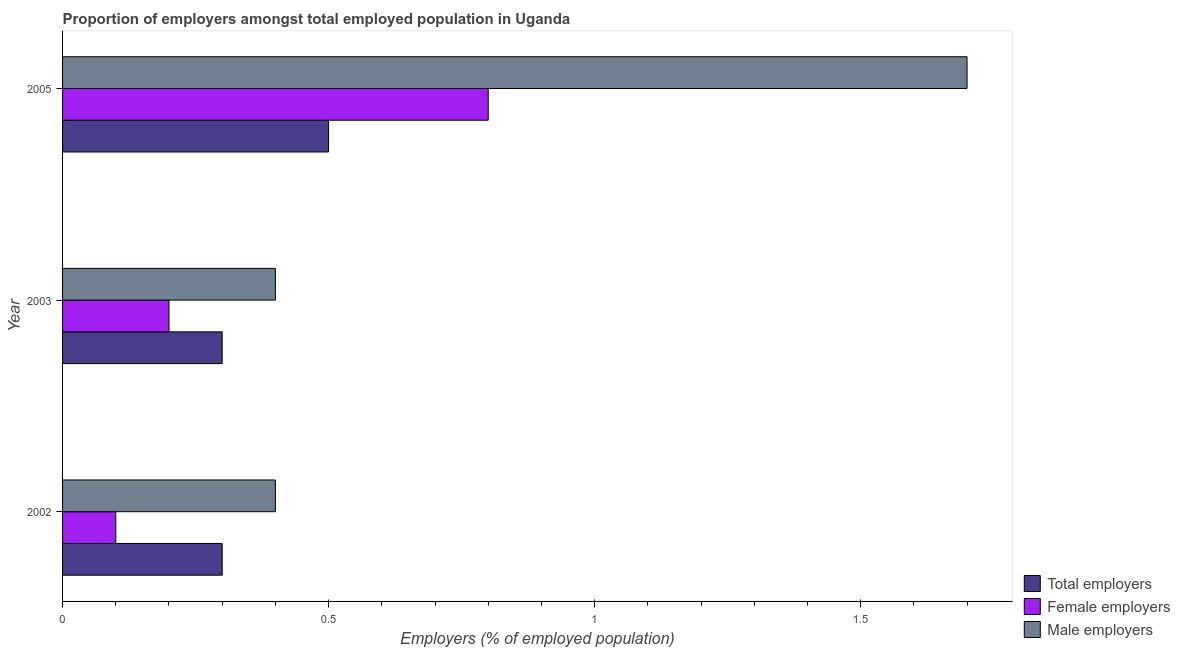How many different coloured bars are there?
Your answer should be compact. 3. How many groups of bars are there?
Your answer should be compact. 3. In how many cases, is the number of bars for a given year not equal to the number of legend labels?
Offer a very short reply. 0. What is the percentage of total employers in 2002?
Ensure brevity in your answer.  0.3. Across all years, what is the maximum percentage of total employers?
Provide a short and direct response. 0.5. Across all years, what is the minimum percentage of female employers?
Keep it short and to the point. 0.1. In which year was the percentage of total employers maximum?
Offer a terse response. 2005. What is the total percentage of male employers in the graph?
Provide a short and direct response. 2.5. What is the difference between the percentage of total employers in 2002 and that in 2003?
Offer a very short reply. 0. What is the difference between the percentage of male employers in 2003 and the percentage of total employers in 2005?
Provide a short and direct response. -0.1. What is the average percentage of total employers per year?
Offer a very short reply. 0.37. In the year 2003, what is the difference between the percentage of male employers and percentage of female employers?
Your response must be concise. 0.2. Is the difference between the percentage of female employers in 2002 and 2005 greater than the difference between the percentage of total employers in 2002 and 2005?
Keep it short and to the point. No. In how many years, is the percentage of total employers greater than the average percentage of total employers taken over all years?
Your answer should be compact. 1. What does the 1st bar from the top in 2002 represents?
Ensure brevity in your answer.  Male employers. What does the 2nd bar from the bottom in 2003 represents?
Ensure brevity in your answer.  Female employers. Is it the case that in every year, the sum of the percentage of total employers and percentage of female employers is greater than the percentage of male employers?
Provide a succinct answer. No. Are the values on the major ticks of X-axis written in scientific E-notation?
Ensure brevity in your answer.  No. Where does the legend appear in the graph?
Offer a terse response. Bottom right. What is the title of the graph?
Your response must be concise. Proportion of employers amongst total employed population in Uganda. Does "Taxes on income" appear as one of the legend labels in the graph?
Offer a very short reply. No. What is the label or title of the X-axis?
Provide a short and direct response. Employers (% of employed population). What is the Employers (% of employed population) in Total employers in 2002?
Offer a terse response. 0.3. What is the Employers (% of employed population) in Female employers in 2002?
Your response must be concise. 0.1. What is the Employers (% of employed population) in Male employers in 2002?
Your answer should be compact. 0.4. What is the Employers (% of employed population) of Total employers in 2003?
Give a very brief answer. 0.3. What is the Employers (% of employed population) in Female employers in 2003?
Ensure brevity in your answer.  0.2. What is the Employers (% of employed population) of Male employers in 2003?
Offer a terse response. 0.4. What is the Employers (% of employed population) in Female employers in 2005?
Offer a very short reply. 0.8. What is the Employers (% of employed population) of Male employers in 2005?
Your answer should be very brief. 1.7. Across all years, what is the maximum Employers (% of employed population) of Total employers?
Give a very brief answer. 0.5. Across all years, what is the maximum Employers (% of employed population) in Female employers?
Provide a succinct answer. 0.8. Across all years, what is the maximum Employers (% of employed population) of Male employers?
Your answer should be compact. 1.7. Across all years, what is the minimum Employers (% of employed population) in Total employers?
Make the answer very short. 0.3. Across all years, what is the minimum Employers (% of employed population) of Female employers?
Provide a short and direct response. 0.1. Across all years, what is the minimum Employers (% of employed population) of Male employers?
Your response must be concise. 0.4. What is the total Employers (% of employed population) of Female employers in the graph?
Offer a terse response. 1.1. What is the total Employers (% of employed population) in Male employers in the graph?
Keep it short and to the point. 2.5. What is the difference between the Employers (% of employed population) in Total employers in 2002 and that in 2003?
Provide a short and direct response. 0. What is the difference between the Employers (% of employed population) in Female employers in 2002 and that in 2003?
Your response must be concise. -0.1. What is the difference between the Employers (% of employed population) of Female employers in 2002 and that in 2005?
Offer a very short reply. -0.7. What is the difference between the Employers (% of employed population) in Male employers in 2002 and that in 2005?
Your answer should be very brief. -1.3. What is the difference between the Employers (% of employed population) of Total employers in 2003 and that in 2005?
Ensure brevity in your answer.  -0.2. What is the difference between the Employers (% of employed population) in Female employers in 2003 and that in 2005?
Your answer should be compact. -0.6. What is the difference between the Employers (% of employed population) of Total employers in 2002 and the Employers (% of employed population) of Male employers in 2005?
Ensure brevity in your answer.  -1.4. What is the difference between the Employers (% of employed population) in Female employers in 2003 and the Employers (% of employed population) in Male employers in 2005?
Keep it short and to the point. -1.5. What is the average Employers (% of employed population) of Total employers per year?
Offer a terse response. 0.37. What is the average Employers (% of employed population) in Female employers per year?
Offer a terse response. 0.37. In the year 2002, what is the difference between the Employers (% of employed population) in Total employers and Employers (% of employed population) in Female employers?
Make the answer very short. 0.2. In the year 2002, what is the difference between the Employers (% of employed population) in Female employers and Employers (% of employed population) in Male employers?
Make the answer very short. -0.3. In the year 2003, what is the difference between the Employers (% of employed population) in Total employers and Employers (% of employed population) in Male employers?
Give a very brief answer. -0.1. In the year 2005, what is the difference between the Employers (% of employed population) in Total employers and Employers (% of employed population) in Male employers?
Make the answer very short. -1.2. What is the ratio of the Employers (% of employed population) of Female employers in 2002 to that in 2003?
Offer a terse response. 0.5. What is the ratio of the Employers (% of employed population) in Male employers in 2002 to that in 2003?
Give a very brief answer. 1. What is the ratio of the Employers (% of employed population) in Total employers in 2002 to that in 2005?
Provide a short and direct response. 0.6. What is the ratio of the Employers (% of employed population) in Female employers in 2002 to that in 2005?
Ensure brevity in your answer.  0.12. What is the ratio of the Employers (% of employed population) of Male employers in 2002 to that in 2005?
Your response must be concise. 0.24. What is the ratio of the Employers (% of employed population) of Female employers in 2003 to that in 2005?
Keep it short and to the point. 0.25. What is the ratio of the Employers (% of employed population) of Male employers in 2003 to that in 2005?
Your answer should be compact. 0.24. What is the difference between the highest and the second highest Employers (% of employed population) in Total employers?
Your response must be concise. 0.2. What is the difference between the highest and the second highest Employers (% of employed population) of Female employers?
Your answer should be compact. 0.6. What is the difference between the highest and the second highest Employers (% of employed population) in Male employers?
Your response must be concise. 1.3. 